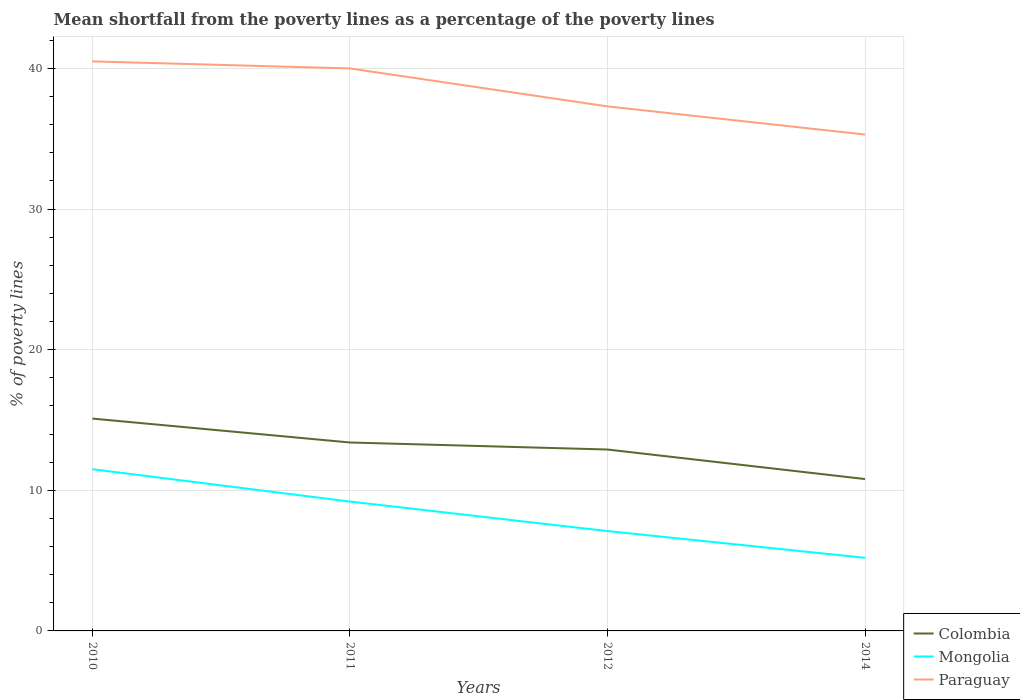How many different coloured lines are there?
Offer a terse response. 3. Is the number of lines equal to the number of legend labels?
Provide a succinct answer. Yes. Across all years, what is the maximum mean shortfall from the poverty lines as a percentage of the poverty lines in Mongolia?
Make the answer very short. 5.2. In which year was the mean shortfall from the poverty lines as a percentage of the poverty lines in Colombia maximum?
Provide a short and direct response. 2014. What is the total mean shortfall from the poverty lines as a percentage of the poverty lines in Colombia in the graph?
Provide a short and direct response. 2.1. What is the difference between the highest and the second highest mean shortfall from the poverty lines as a percentage of the poverty lines in Colombia?
Your answer should be very brief. 4.3. What is the difference between the highest and the lowest mean shortfall from the poverty lines as a percentage of the poverty lines in Paraguay?
Give a very brief answer. 2. Is the mean shortfall from the poverty lines as a percentage of the poverty lines in Colombia strictly greater than the mean shortfall from the poverty lines as a percentage of the poverty lines in Mongolia over the years?
Provide a succinct answer. No. How many years are there in the graph?
Provide a short and direct response. 4. Are the values on the major ticks of Y-axis written in scientific E-notation?
Provide a succinct answer. No. Does the graph contain grids?
Ensure brevity in your answer.  Yes. What is the title of the graph?
Provide a short and direct response. Mean shortfall from the poverty lines as a percentage of the poverty lines. What is the label or title of the X-axis?
Make the answer very short. Years. What is the label or title of the Y-axis?
Keep it short and to the point. % of poverty lines. What is the % of poverty lines in Mongolia in 2010?
Ensure brevity in your answer.  11.5. What is the % of poverty lines of Paraguay in 2010?
Offer a terse response. 40.5. What is the % of poverty lines in Colombia in 2011?
Your answer should be very brief. 13.4. What is the % of poverty lines of Mongolia in 2011?
Your answer should be very brief. 9.2. What is the % of poverty lines of Paraguay in 2011?
Offer a terse response. 40. What is the % of poverty lines in Mongolia in 2012?
Offer a terse response. 7.1. What is the % of poverty lines of Paraguay in 2012?
Offer a very short reply. 37.3. What is the % of poverty lines in Colombia in 2014?
Offer a terse response. 10.8. What is the % of poverty lines in Paraguay in 2014?
Your answer should be compact. 35.3. Across all years, what is the maximum % of poverty lines in Paraguay?
Your answer should be compact. 40.5. Across all years, what is the minimum % of poverty lines of Colombia?
Make the answer very short. 10.8. Across all years, what is the minimum % of poverty lines of Paraguay?
Offer a very short reply. 35.3. What is the total % of poverty lines in Colombia in the graph?
Offer a terse response. 52.2. What is the total % of poverty lines of Paraguay in the graph?
Make the answer very short. 153.1. What is the difference between the % of poverty lines of Colombia in 2010 and that in 2011?
Make the answer very short. 1.7. What is the difference between the % of poverty lines of Mongolia in 2010 and that in 2011?
Give a very brief answer. 2.3. What is the difference between the % of poverty lines in Colombia in 2010 and that in 2012?
Give a very brief answer. 2.2. What is the difference between the % of poverty lines in Paraguay in 2010 and that in 2012?
Provide a succinct answer. 3.2. What is the difference between the % of poverty lines of Colombia in 2010 and that in 2014?
Offer a terse response. 4.3. What is the difference between the % of poverty lines in Paraguay in 2010 and that in 2014?
Make the answer very short. 5.2. What is the difference between the % of poverty lines in Colombia in 2011 and that in 2012?
Provide a succinct answer. 0.5. What is the difference between the % of poverty lines of Mongolia in 2011 and that in 2012?
Your response must be concise. 2.1. What is the difference between the % of poverty lines in Mongolia in 2011 and that in 2014?
Keep it short and to the point. 4. What is the difference between the % of poverty lines of Paraguay in 2011 and that in 2014?
Offer a very short reply. 4.7. What is the difference between the % of poverty lines in Colombia in 2012 and that in 2014?
Your response must be concise. 2.1. What is the difference between the % of poverty lines in Mongolia in 2012 and that in 2014?
Offer a terse response. 1.9. What is the difference between the % of poverty lines in Colombia in 2010 and the % of poverty lines in Mongolia in 2011?
Your answer should be compact. 5.9. What is the difference between the % of poverty lines of Colombia in 2010 and the % of poverty lines of Paraguay in 2011?
Give a very brief answer. -24.9. What is the difference between the % of poverty lines in Mongolia in 2010 and the % of poverty lines in Paraguay in 2011?
Your answer should be compact. -28.5. What is the difference between the % of poverty lines of Colombia in 2010 and the % of poverty lines of Mongolia in 2012?
Ensure brevity in your answer.  8. What is the difference between the % of poverty lines in Colombia in 2010 and the % of poverty lines in Paraguay in 2012?
Offer a very short reply. -22.2. What is the difference between the % of poverty lines of Mongolia in 2010 and the % of poverty lines of Paraguay in 2012?
Keep it short and to the point. -25.8. What is the difference between the % of poverty lines in Colombia in 2010 and the % of poverty lines in Paraguay in 2014?
Keep it short and to the point. -20.2. What is the difference between the % of poverty lines of Mongolia in 2010 and the % of poverty lines of Paraguay in 2014?
Your response must be concise. -23.8. What is the difference between the % of poverty lines of Colombia in 2011 and the % of poverty lines of Paraguay in 2012?
Your answer should be very brief. -23.9. What is the difference between the % of poverty lines of Mongolia in 2011 and the % of poverty lines of Paraguay in 2012?
Ensure brevity in your answer.  -28.1. What is the difference between the % of poverty lines of Colombia in 2011 and the % of poverty lines of Paraguay in 2014?
Your answer should be very brief. -21.9. What is the difference between the % of poverty lines of Mongolia in 2011 and the % of poverty lines of Paraguay in 2014?
Give a very brief answer. -26.1. What is the difference between the % of poverty lines in Colombia in 2012 and the % of poverty lines in Mongolia in 2014?
Provide a succinct answer. 7.7. What is the difference between the % of poverty lines in Colombia in 2012 and the % of poverty lines in Paraguay in 2014?
Provide a short and direct response. -22.4. What is the difference between the % of poverty lines in Mongolia in 2012 and the % of poverty lines in Paraguay in 2014?
Provide a succinct answer. -28.2. What is the average % of poverty lines of Colombia per year?
Provide a succinct answer. 13.05. What is the average % of poverty lines of Mongolia per year?
Offer a terse response. 8.25. What is the average % of poverty lines in Paraguay per year?
Keep it short and to the point. 38.27. In the year 2010, what is the difference between the % of poverty lines in Colombia and % of poverty lines in Paraguay?
Provide a short and direct response. -25.4. In the year 2010, what is the difference between the % of poverty lines in Mongolia and % of poverty lines in Paraguay?
Your answer should be very brief. -29. In the year 2011, what is the difference between the % of poverty lines in Colombia and % of poverty lines in Mongolia?
Offer a terse response. 4.2. In the year 2011, what is the difference between the % of poverty lines of Colombia and % of poverty lines of Paraguay?
Offer a very short reply. -26.6. In the year 2011, what is the difference between the % of poverty lines of Mongolia and % of poverty lines of Paraguay?
Ensure brevity in your answer.  -30.8. In the year 2012, what is the difference between the % of poverty lines in Colombia and % of poverty lines in Mongolia?
Offer a very short reply. 5.8. In the year 2012, what is the difference between the % of poverty lines of Colombia and % of poverty lines of Paraguay?
Your answer should be compact. -24.4. In the year 2012, what is the difference between the % of poverty lines of Mongolia and % of poverty lines of Paraguay?
Your answer should be compact. -30.2. In the year 2014, what is the difference between the % of poverty lines in Colombia and % of poverty lines in Paraguay?
Make the answer very short. -24.5. In the year 2014, what is the difference between the % of poverty lines of Mongolia and % of poverty lines of Paraguay?
Ensure brevity in your answer.  -30.1. What is the ratio of the % of poverty lines in Colombia in 2010 to that in 2011?
Give a very brief answer. 1.13. What is the ratio of the % of poverty lines of Paraguay in 2010 to that in 2011?
Ensure brevity in your answer.  1.01. What is the ratio of the % of poverty lines of Colombia in 2010 to that in 2012?
Your answer should be very brief. 1.17. What is the ratio of the % of poverty lines of Mongolia in 2010 to that in 2012?
Provide a succinct answer. 1.62. What is the ratio of the % of poverty lines of Paraguay in 2010 to that in 2012?
Your answer should be very brief. 1.09. What is the ratio of the % of poverty lines of Colombia in 2010 to that in 2014?
Keep it short and to the point. 1.4. What is the ratio of the % of poverty lines of Mongolia in 2010 to that in 2014?
Your answer should be compact. 2.21. What is the ratio of the % of poverty lines of Paraguay in 2010 to that in 2014?
Give a very brief answer. 1.15. What is the ratio of the % of poverty lines of Colombia in 2011 to that in 2012?
Offer a very short reply. 1.04. What is the ratio of the % of poverty lines in Mongolia in 2011 to that in 2012?
Ensure brevity in your answer.  1.3. What is the ratio of the % of poverty lines in Paraguay in 2011 to that in 2012?
Give a very brief answer. 1.07. What is the ratio of the % of poverty lines of Colombia in 2011 to that in 2014?
Ensure brevity in your answer.  1.24. What is the ratio of the % of poverty lines in Mongolia in 2011 to that in 2014?
Your answer should be compact. 1.77. What is the ratio of the % of poverty lines of Paraguay in 2011 to that in 2014?
Ensure brevity in your answer.  1.13. What is the ratio of the % of poverty lines in Colombia in 2012 to that in 2014?
Your response must be concise. 1.19. What is the ratio of the % of poverty lines in Mongolia in 2012 to that in 2014?
Your answer should be compact. 1.37. What is the ratio of the % of poverty lines in Paraguay in 2012 to that in 2014?
Your answer should be compact. 1.06. What is the difference between the highest and the second highest % of poverty lines of Mongolia?
Ensure brevity in your answer.  2.3. What is the difference between the highest and the lowest % of poverty lines in Colombia?
Provide a short and direct response. 4.3. 